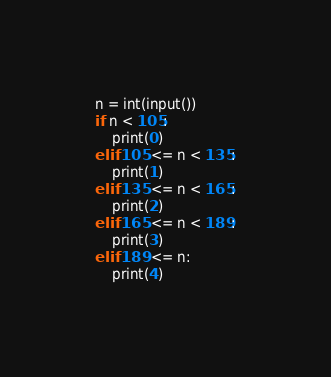Convert code to text. <code><loc_0><loc_0><loc_500><loc_500><_Python_>n = int(input())
if n < 105:
    print(0)
elif 105 <= n < 135:
    print(1)
elif 135 <= n < 165:
    print(2)
elif 165 <= n < 189:
    print(3)
elif 189 <= n:
    print(4)
</code> 